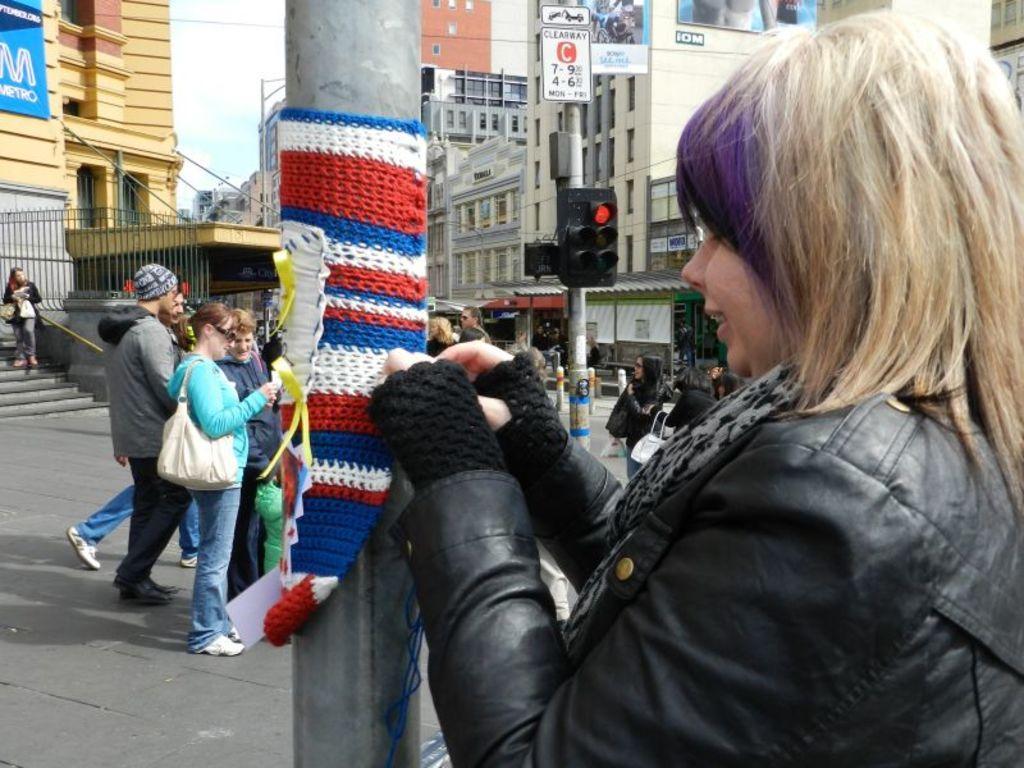Can you describe this image briefly? In this image there are buildings, poles, signal lights, boards, hoardings, railing, steps, people, sky and objects. People wore jackets. Near them there are objects. In the front of the image I can see woolen cloth is on the pole. Something is written on the boards and hoardings.   